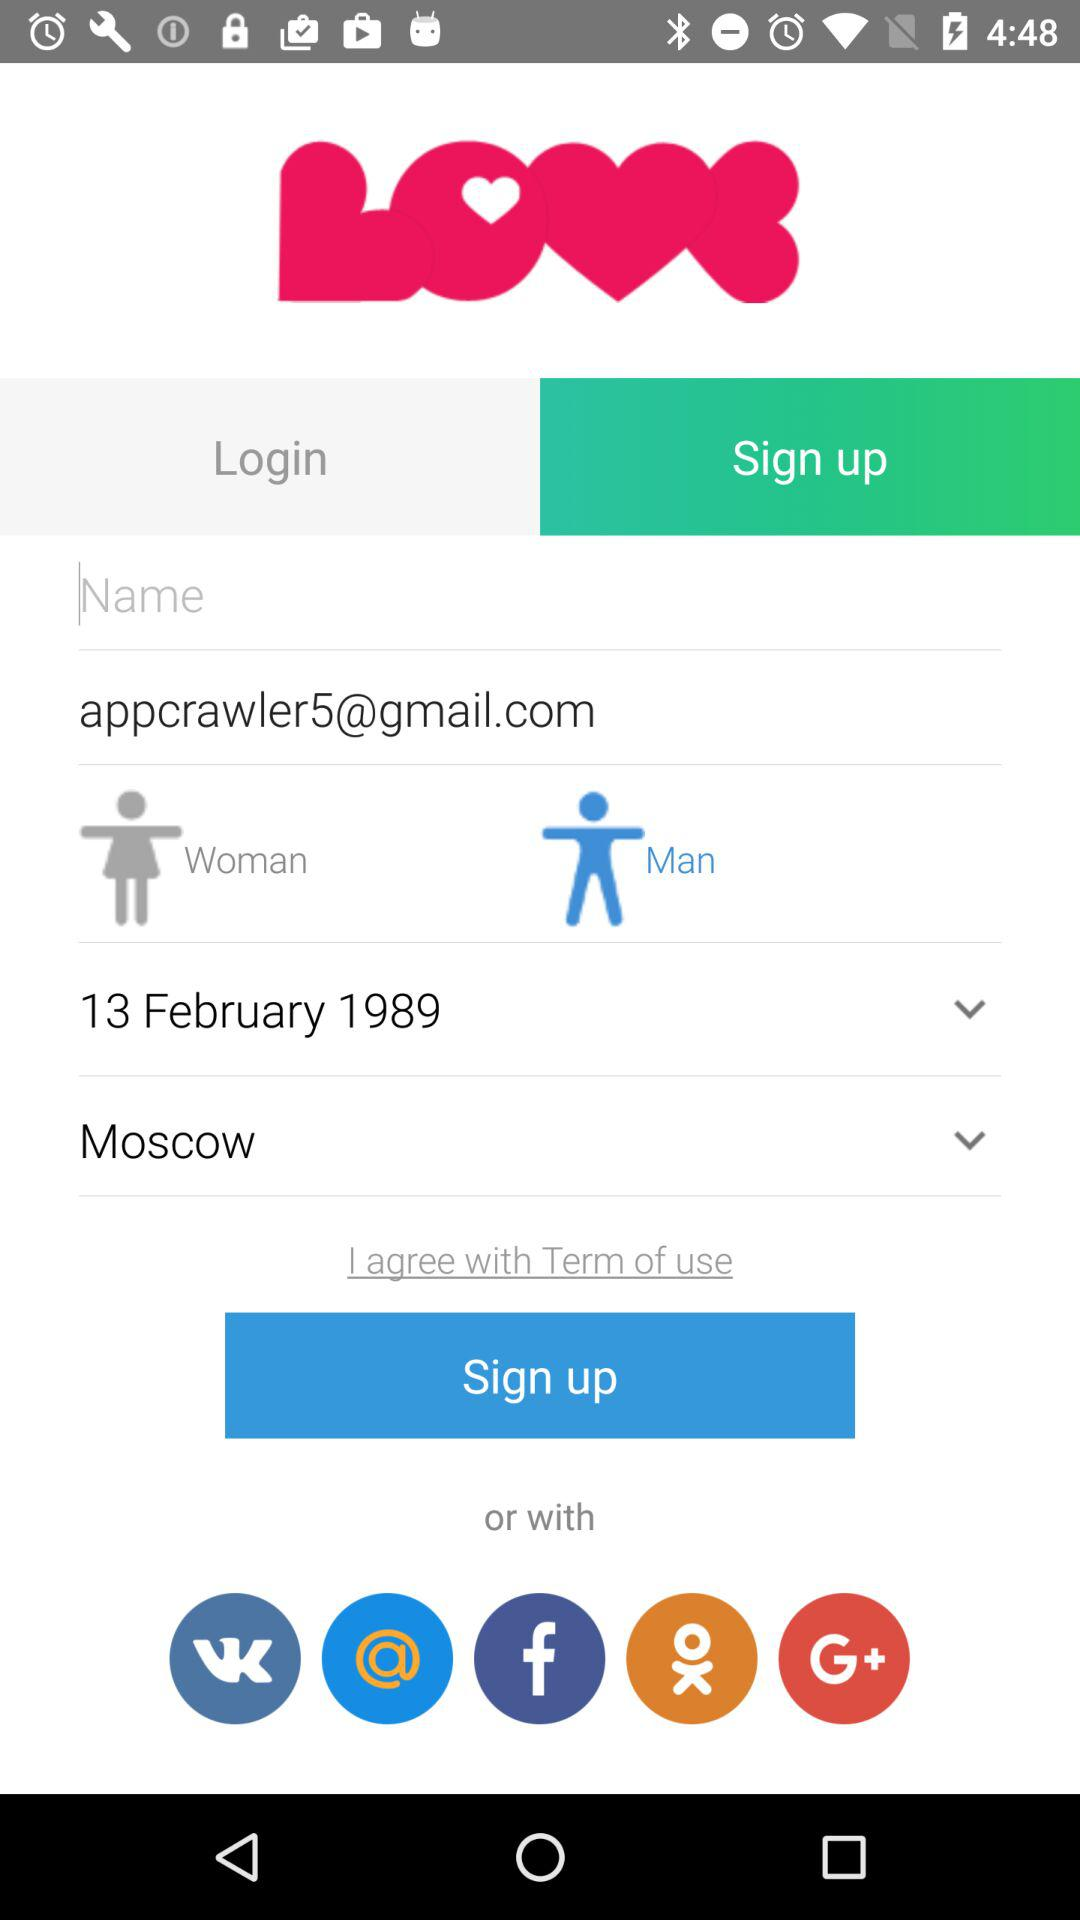What is the date? The date is February 13, 1989. 